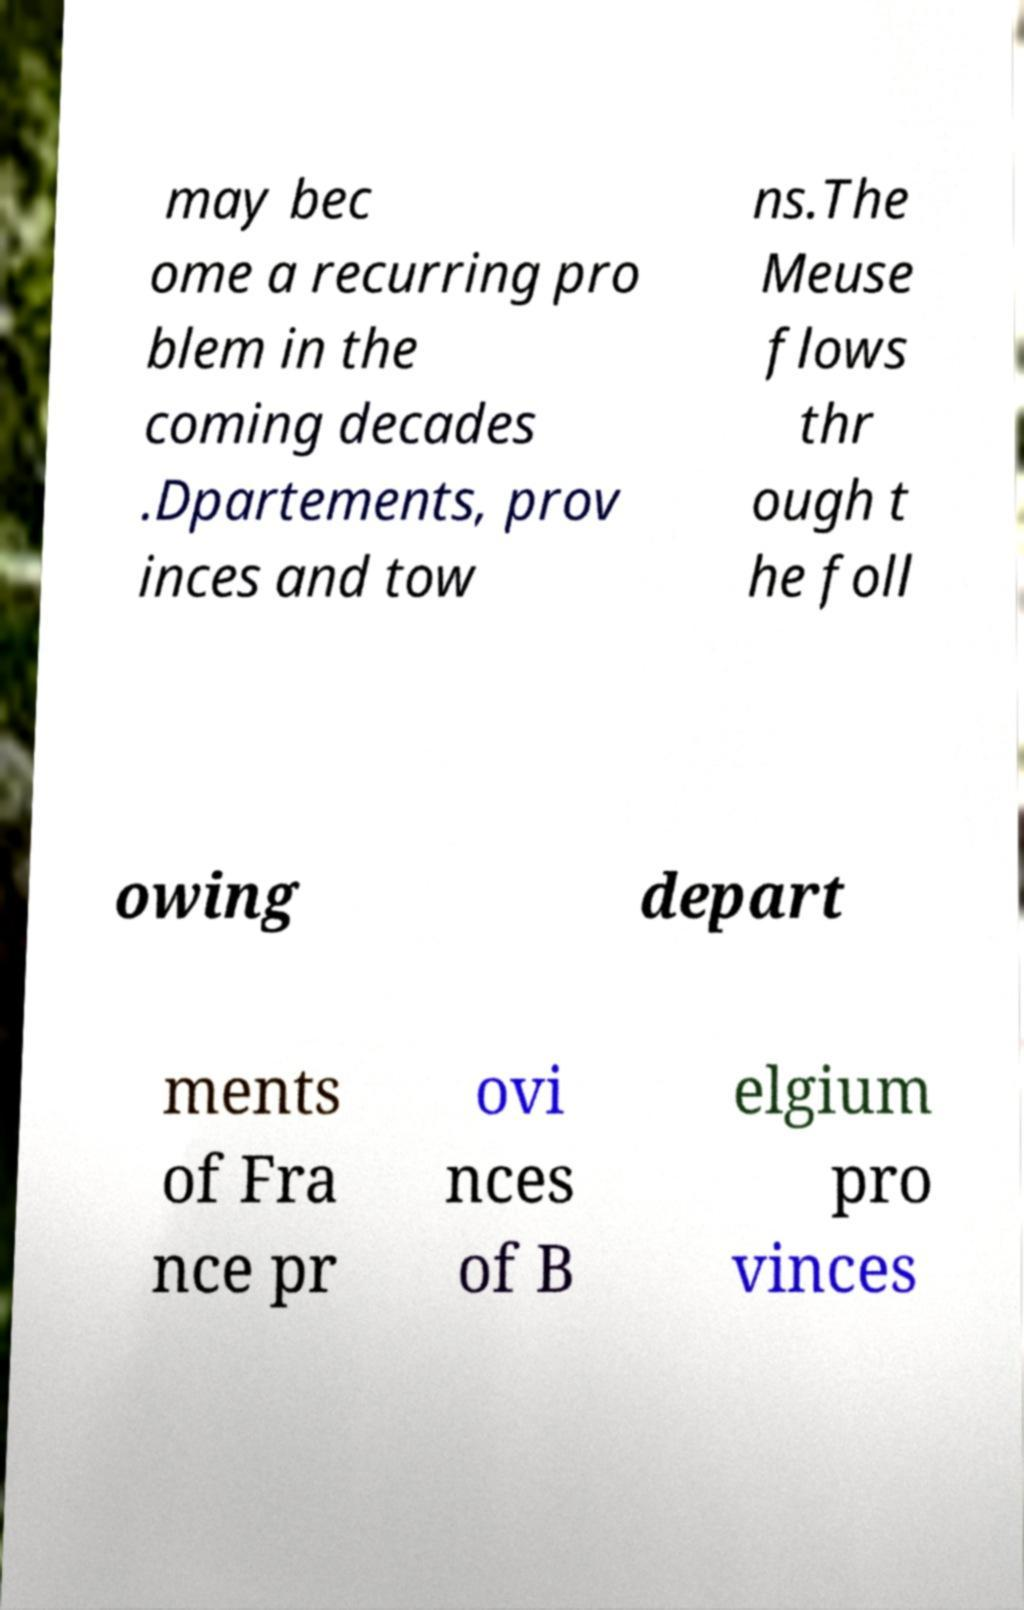Could you assist in decoding the text presented in this image and type it out clearly? may bec ome a recurring pro blem in the coming decades .Dpartements, prov inces and tow ns.The Meuse flows thr ough t he foll owing depart ments of Fra nce pr ovi nces of B elgium pro vinces 